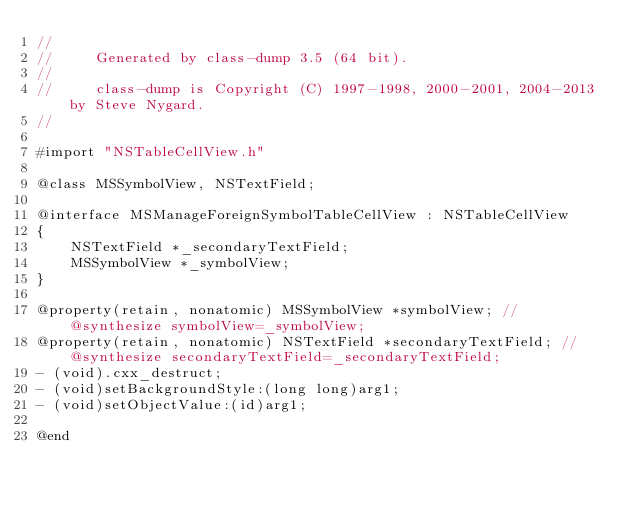<code> <loc_0><loc_0><loc_500><loc_500><_C_>//
//     Generated by class-dump 3.5 (64 bit).
//
//     class-dump is Copyright (C) 1997-1998, 2000-2001, 2004-2013 by Steve Nygard.
//

#import "NSTableCellView.h"

@class MSSymbolView, NSTextField;

@interface MSManageForeignSymbolTableCellView : NSTableCellView
{
    NSTextField *_secondaryTextField;
    MSSymbolView *_symbolView;
}

@property(retain, nonatomic) MSSymbolView *symbolView; // @synthesize symbolView=_symbolView;
@property(retain, nonatomic) NSTextField *secondaryTextField; // @synthesize secondaryTextField=_secondaryTextField;
- (void).cxx_destruct;
- (void)setBackgroundStyle:(long long)arg1;
- (void)setObjectValue:(id)arg1;

@end

</code> 